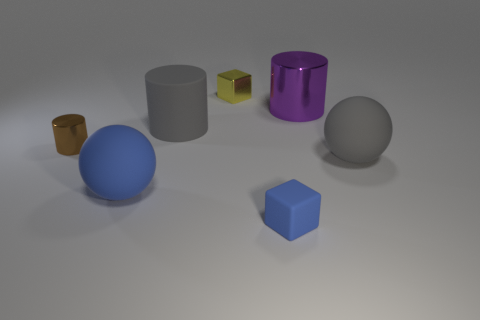What color is the metal block that is to the left of the blue thing to the right of the yellow block?
Your answer should be very brief. Yellow. There is a small matte thing; does it have the same color as the matte sphere that is on the right side of the big blue matte sphere?
Give a very brief answer. No. There is a small yellow block to the right of the matte ball that is left of the large shiny cylinder; how many small brown metallic things are behind it?
Keep it short and to the point. 0. There is a gray sphere; are there any matte things behind it?
Offer a very short reply. Yes. Are there any other things that are the same color as the shiny block?
Your response must be concise. No. How many spheres are yellow shiny things or big purple things?
Your answer should be compact. 0. How many matte objects are both behind the blue rubber cube and left of the purple thing?
Provide a succinct answer. 2. Are there an equal number of brown things that are in front of the small cylinder and small rubber objects behind the blue ball?
Your answer should be compact. Yes. There is a big gray object to the left of the small blue thing; does it have the same shape as the tiny matte object?
Offer a very short reply. No. What is the shape of the tiny object that is in front of the rubber ball behind the large sphere on the left side of the tiny blue matte cube?
Keep it short and to the point. Cube. 